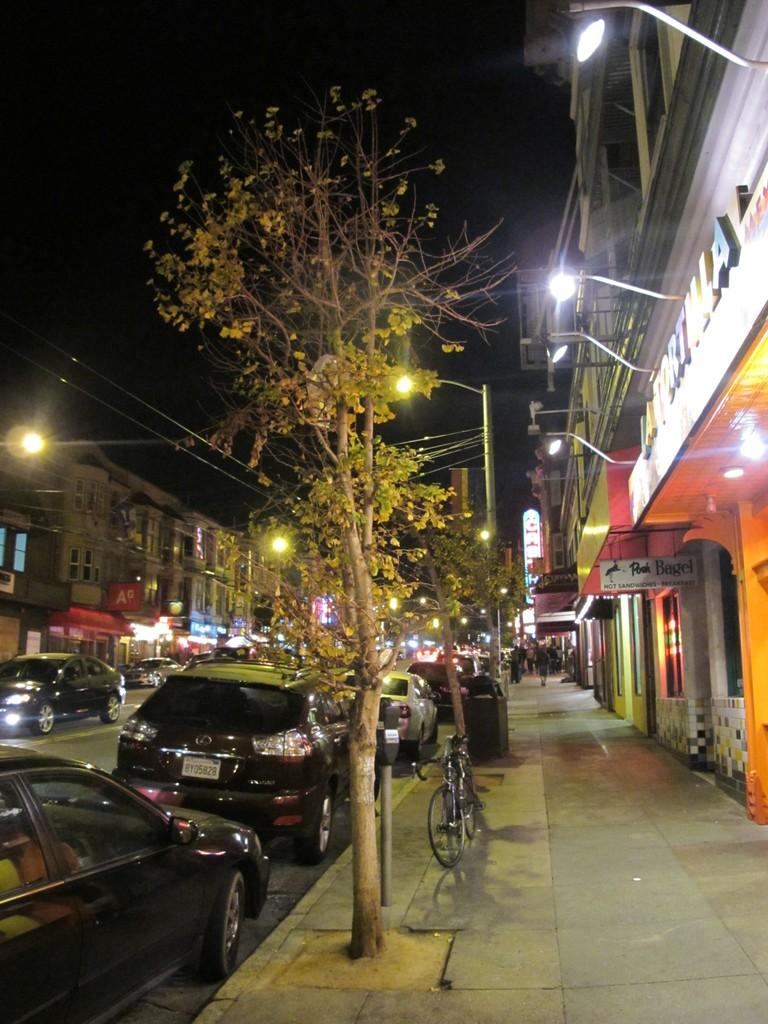What can be seen on the road in the image? There are vehicles on the road in the image. What type of structures are visible in the image? There are buildings in the image. What are the poles and wires used for in the image? The poles and wires are likely used for supporting and transmitting electricity or communication signals. Can you describe the people in the image? There are people in the image, but their specific actions or appearances are not mentioned in the facts. What type of lighting is present in the image? There are lights in the image, but their specific purpose or location is not mentioned in the facts. What type of vegetation is visible in the image? There are trees in the image. What type of signage is present in the image? There are boards with text in the image. What type of transportation can be seen in the image? There is a bicycle in the image. How does the image control the movement of sheep? The image does not control the movement of sheep, as there is no mention of sheep in the provided facts. What type of air is present in the image? The image does not depict a specific type of air, as air is not visible. 